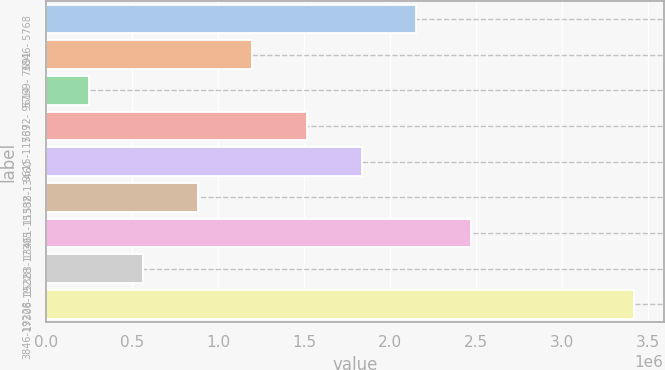<chart> <loc_0><loc_0><loc_500><loc_500><bar_chart><fcel>3846- 5768<fcel>5769- 7691<fcel>7692- 9614<fcel>9615-11537<fcel>11538-13460<fcel>13461-15382<fcel>15383-17305<fcel>17306-19228<fcel>3846-19228<nl><fcel>2.15147e+06<fcel>1.20038e+06<fcel>249281<fcel>1.51741e+06<fcel>1.83444e+06<fcel>883344<fcel>2.4685e+06<fcel>566313<fcel>3.4196e+06<nl></chart> 